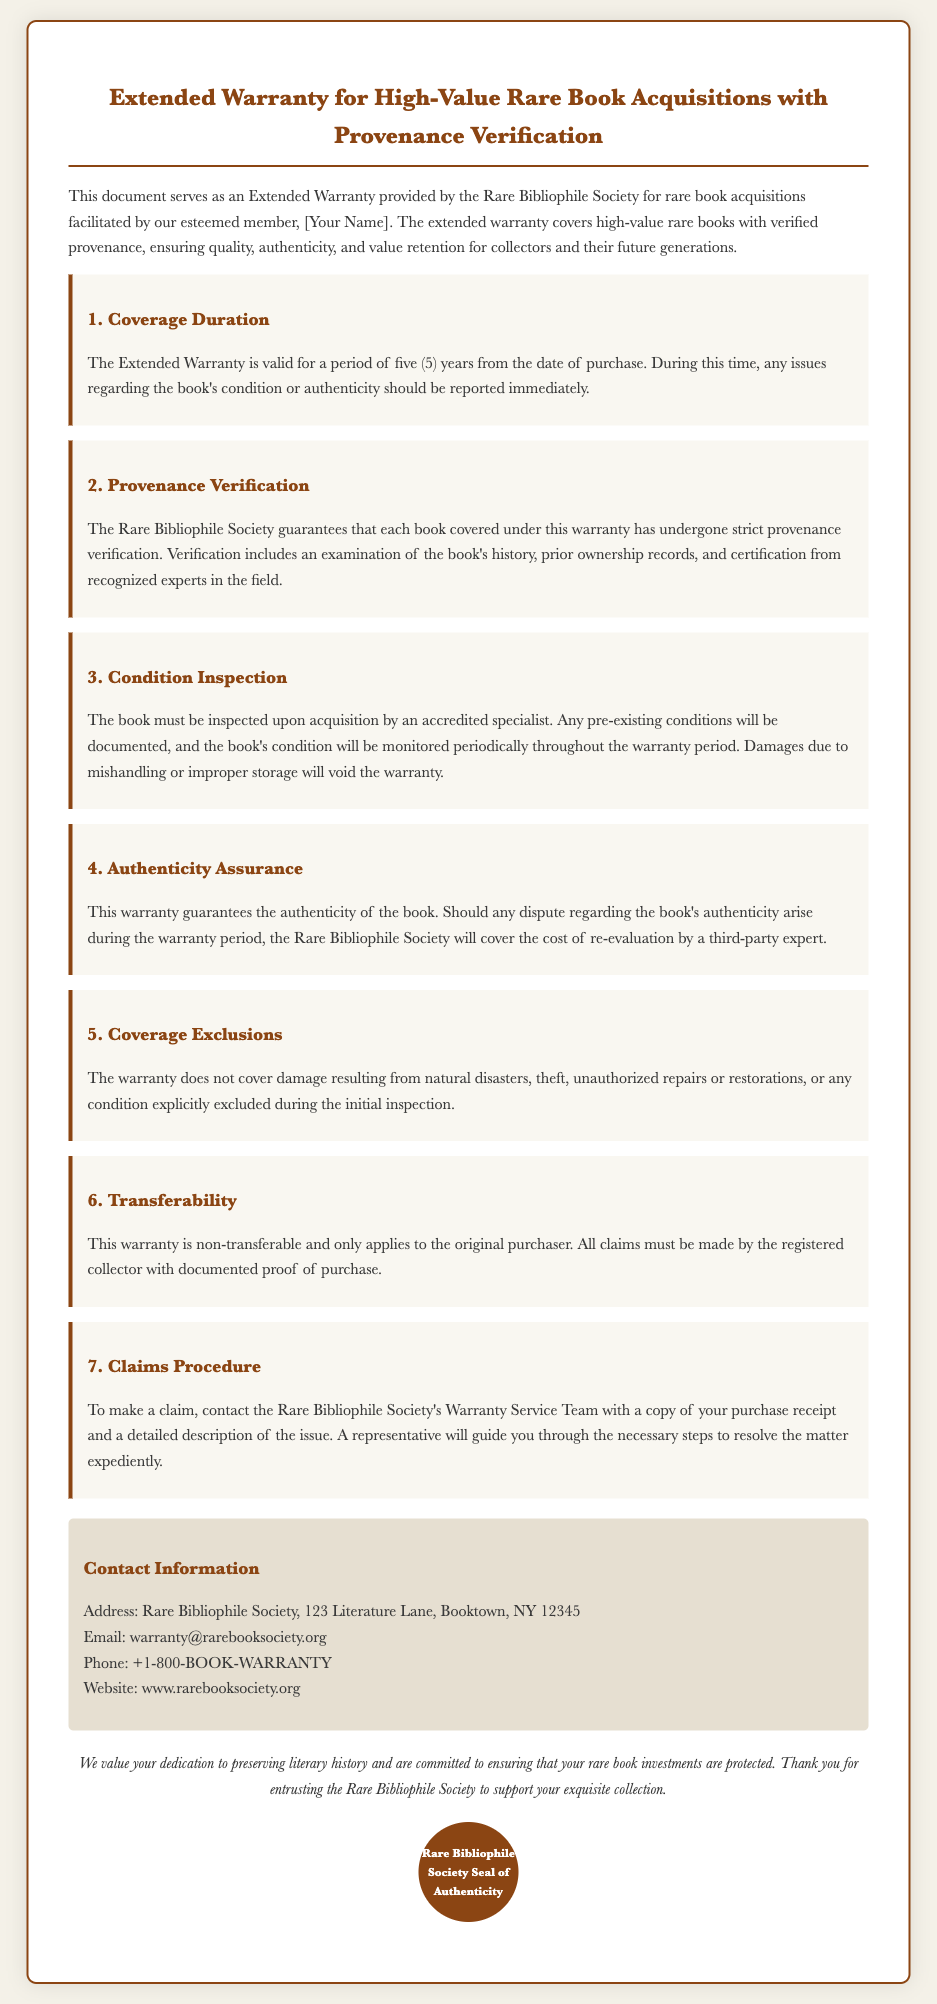What is the validity period of the Extended Warranty? The warranty is valid for a period, which is explicitly stated in the document.
Answer: five (5) years What does the Rare Bibliophile Society guarantee regarding authenticity? The document states the warranty guarantees authenticity and what actions will be taken in case of disputes.
Answer: authenticity What is required for condition inspection? The document specifies who must conduct the inspection upon acquisition.
Answer: accredited specialist What does the warranty exclude? The document lists exclusions from the warranty coverage.
Answer: natural disasters How must claims be submitted? The document outlines the procedure to make a claim and what information must be included.
Answer: contact the Rare Bibliophile Society's Warranty Service Team Is this warranty transferable? The document states whether the warranty can be transferred to another party.
Answer: non-transferable What type of book does the warranty cover? The warranty is specific to a category of items that can be verified.
Answer: high-value rare books What is the contact email for warranty services? The document provides contact information including an email address for claims.
Answer: warranty@rarebooksociety.org What does the warranty cover regarding provenance? The document details what the Rare Bibliophile Society ensures about the books in terms of history.
Answer: strict provenance verification 